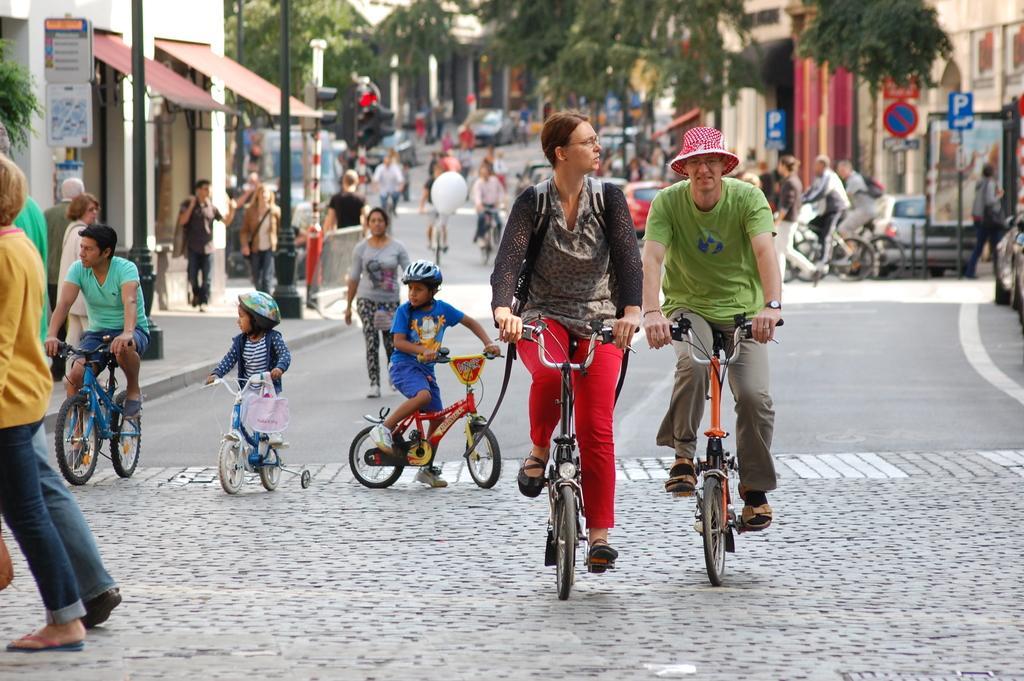Describe this image in one or two sentences. people are riding bicycles on the road. in the front there is person standing at the right corner there is a tree and sign boards. at the left there are buildings and traffic signals. 